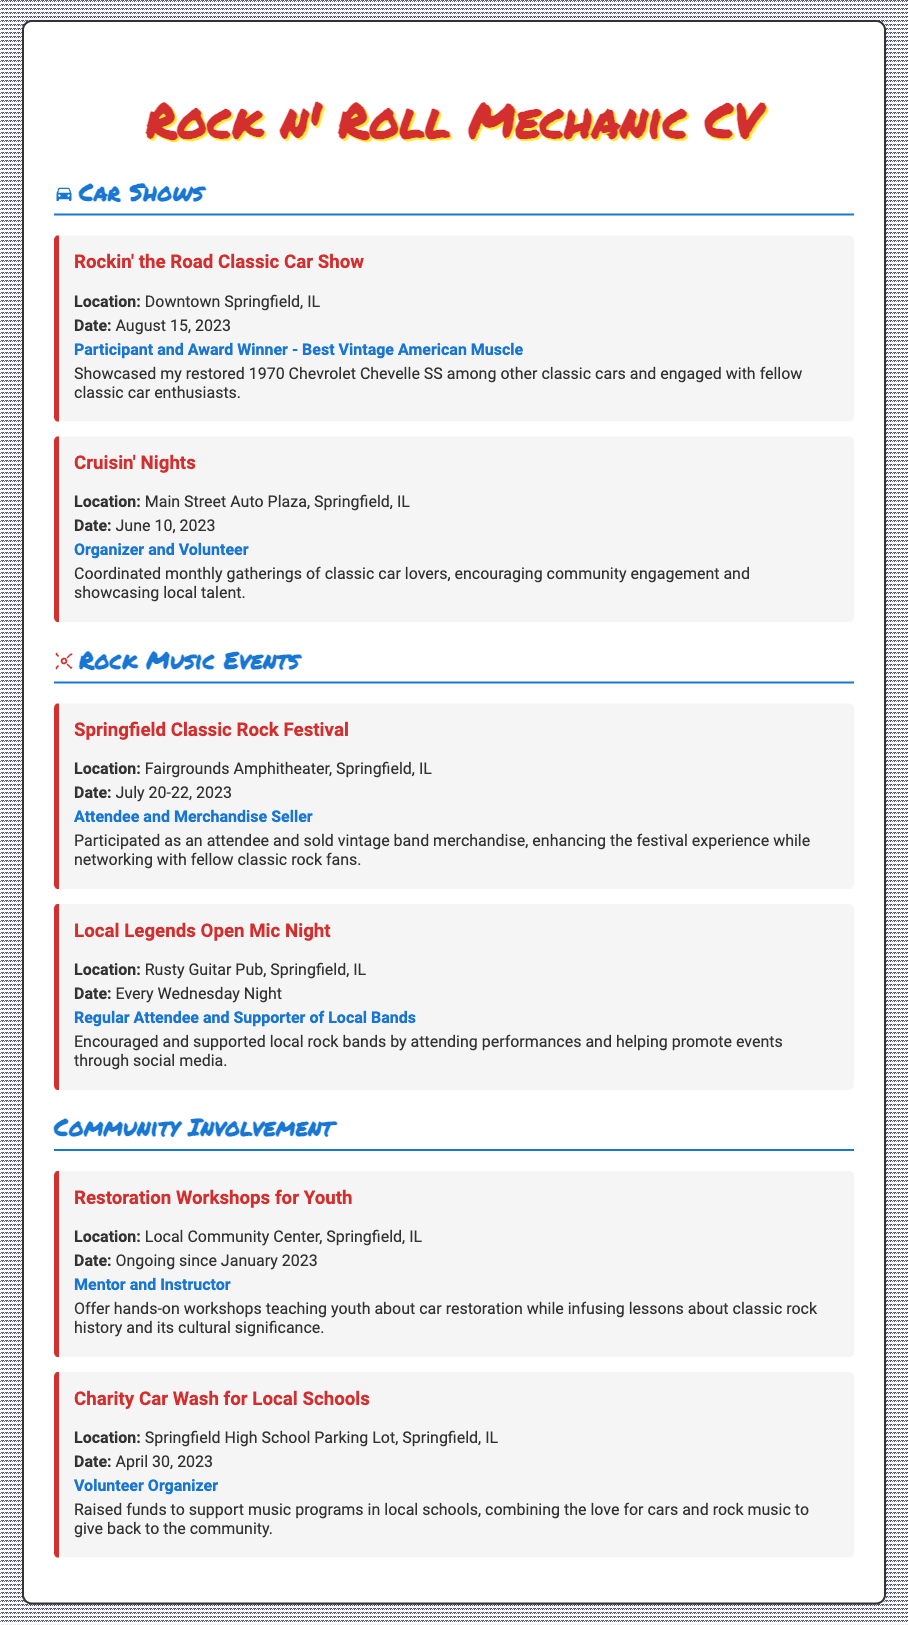What is the name of the participant award won? The document states that the participant won an award for "Best Vintage American Muscle" at the Rockin' the Road Classic Car Show.
Answer: Best Vintage American Muscle What was showcased at the Rockin' the Road Classic Car Show? The individual showcased their restored 1970 Chevrolet Chevelle SS among other classic cars.
Answer: 1970 Chevrolet Chevelle SS When did the Springfield Classic Rock Festival take place? The festival occurred from July 20 to July 22 in 2023 as stated in the document.
Answer: July 20-22, 2023 How many events are listed under Rock Music Events? There are two events detailed in the Rock Music Events section of the document.
Answer: 2 What is the main purpose of the Restoration Workshops for Youth? The workshops aim to teach youth about car restoration while infusing lessons about classic rock history.
Answer: Teach car restoration Who organized the Charity Car Wash for Local Schools? The individual acted as a Volunteer Organizer for the charity car wash, as mentioned in the document.
Answer: Volunteer Organizer What is the frequency of the Local Legends Open Mic Night? The event occurs every Wednesday night according to the details provided.
Answer: Every Wednesday Night Where is the Cruisin' Nights event held? The Cruisin' Nights event takes place at Main Street Auto Plaza, Springfield, IL.
Answer: Main Street Auto Plaza, Springfield, IL 